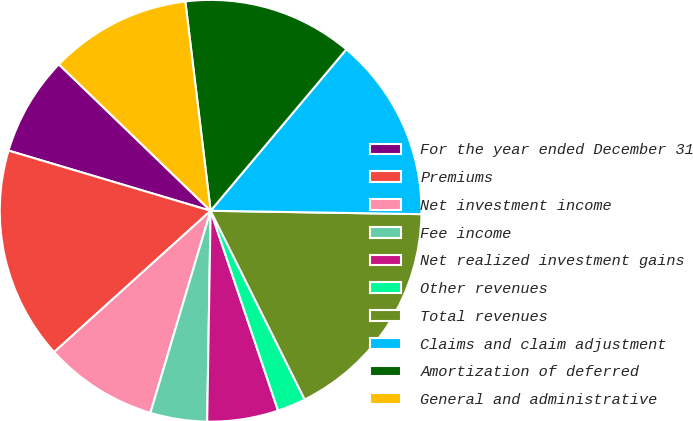<chart> <loc_0><loc_0><loc_500><loc_500><pie_chart><fcel>For the year ended December 31<fcel>Premiums<fcel>Net investment income<fcel>Fee income<fcel>Net realized investment gains<fcel>Other revenues<fcel>Total revenues<fcel>Claims and claim adjustment<fcel>Amortization of deferred<fcel>General and administrative<nl><fcel>7.61%<fcel>16.3%<fcel>8.7%<fcel>4.35%<fcel>5.44%<fcel>2.18%<fcel>17.39%<fcel>14.13%<fcel>13.04%<fcel>10.87%<nl></chart> 